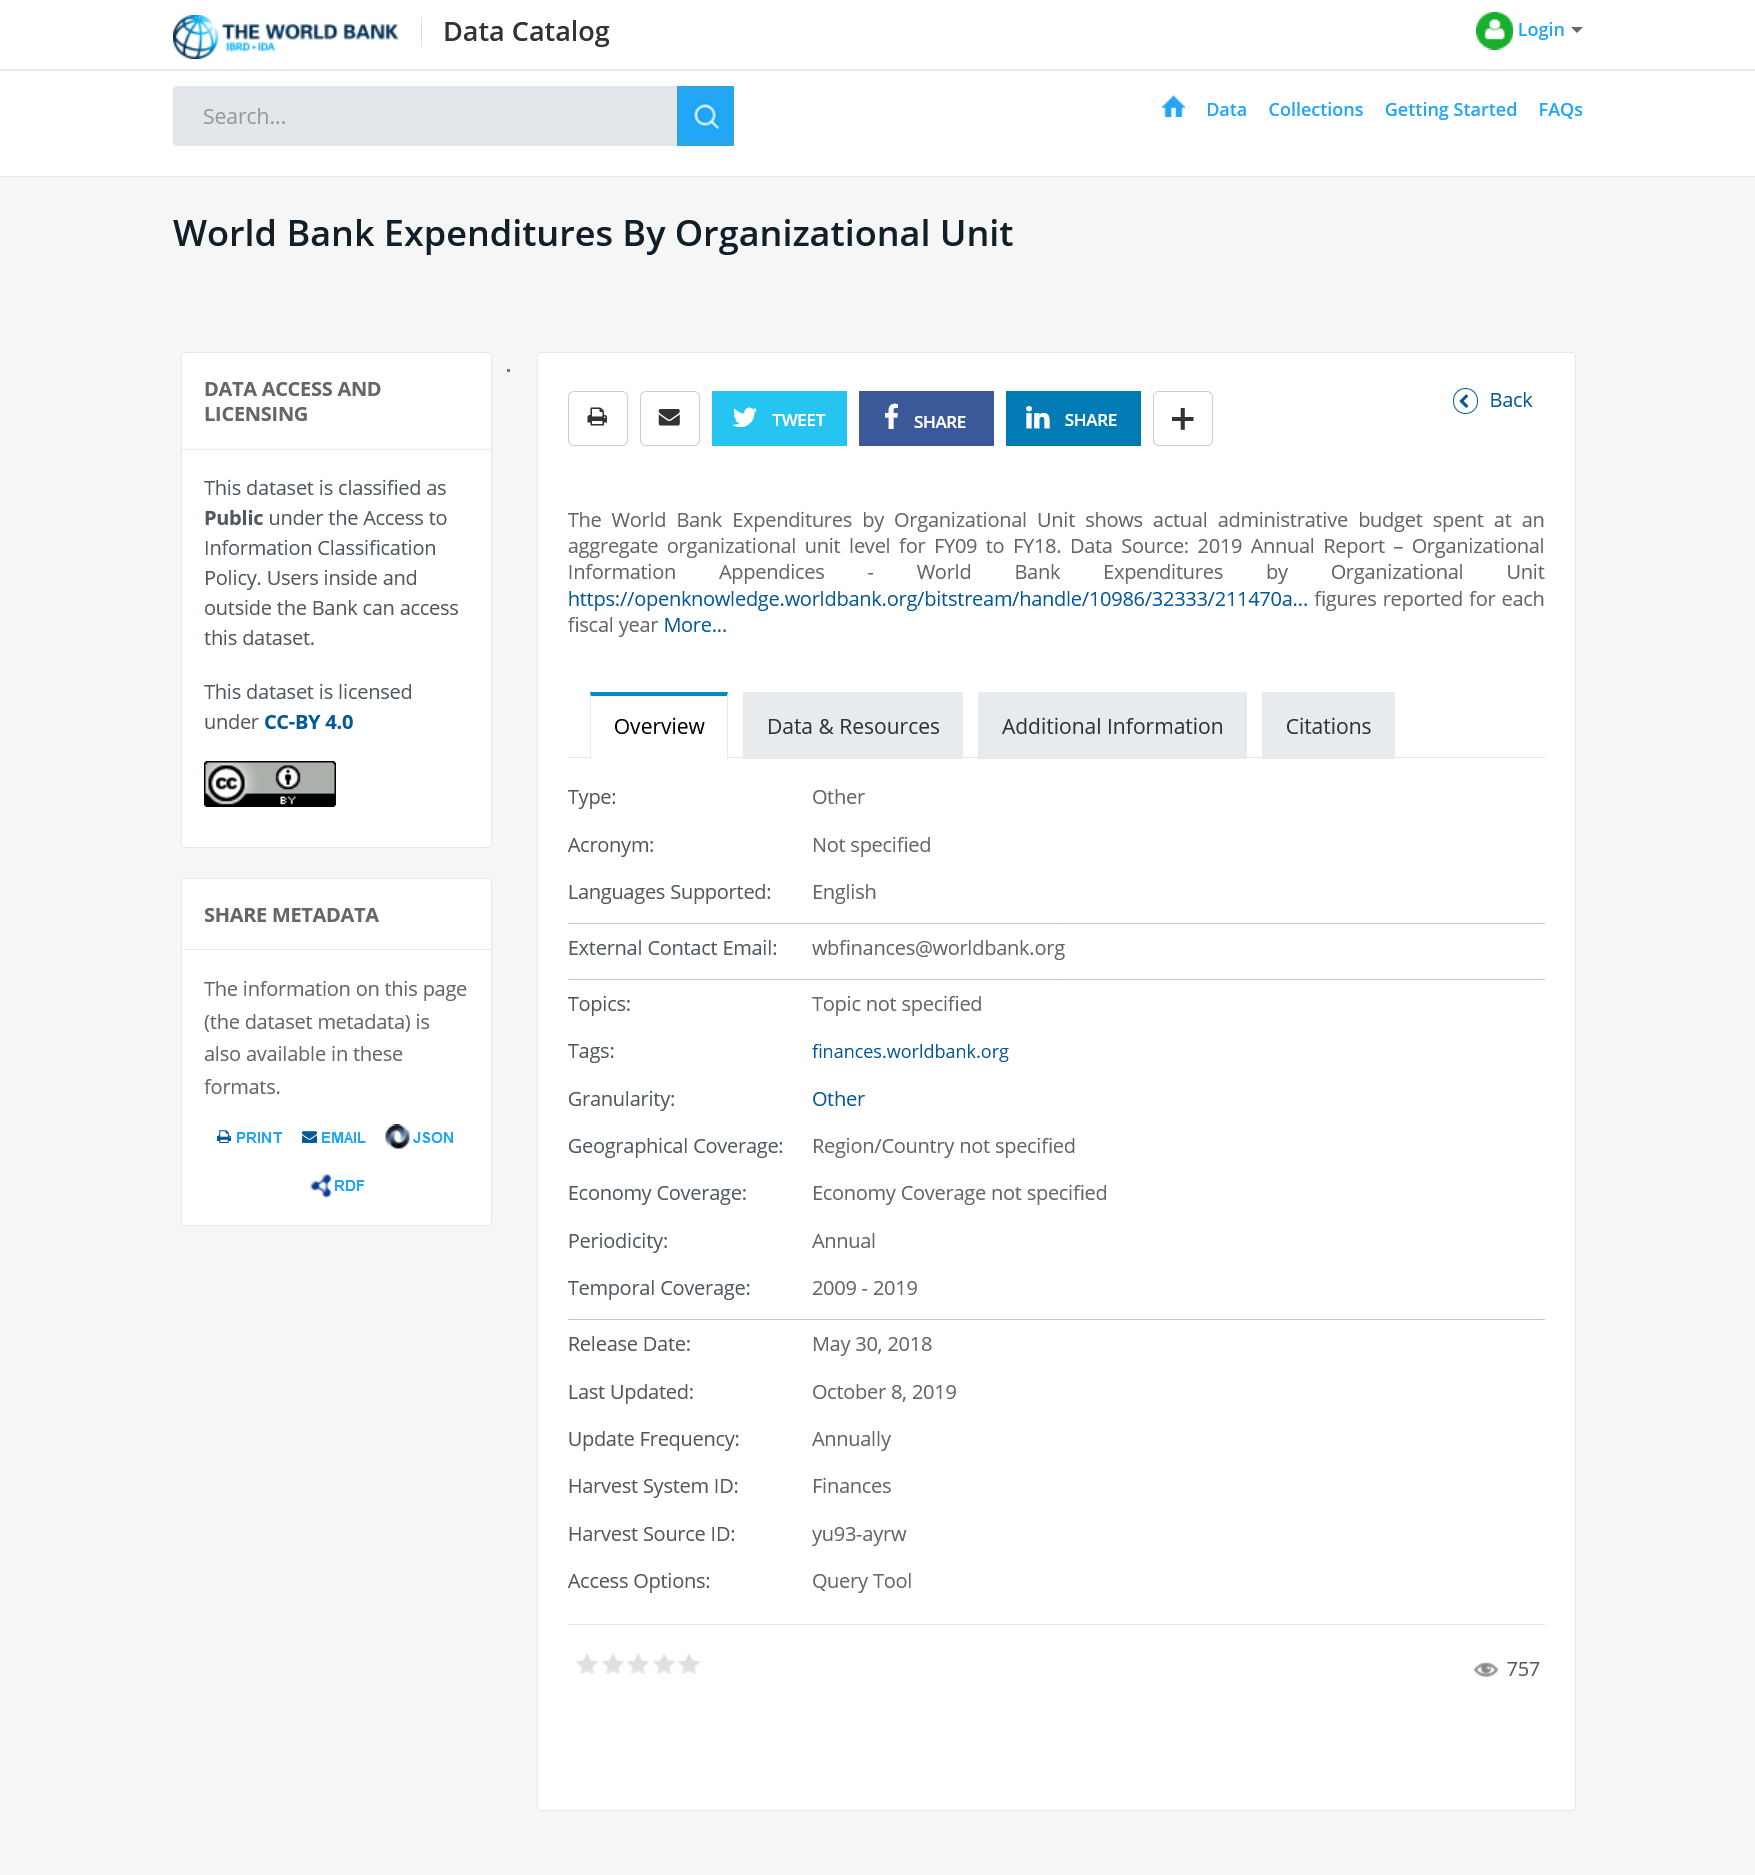Draw attention to some important aspects in this diagram. The World Bank expenditures by organizational unit show the actual administrative budget that has been spent at an aggregate level for each organizational unit. The figures reported for the year are unclear, as they pertain to a fiscal year rather than a calendar year. It is important to clarify the time frame and context in which these figures were generated to fully understand their significance. The World Bank's expenditures are broken down by organizational unit, providing a detailed overview of how funds are allocated. 